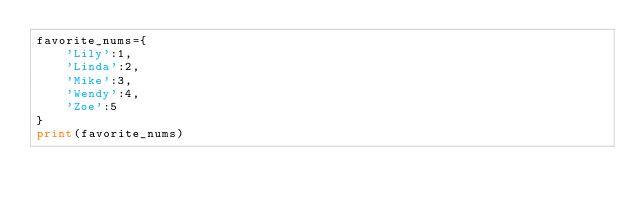Convert code to text. <code><loc_0><loc_0><loc_500><loc_500><_Python_>favorite_nums={
	'Lily':1,
	'Linda':2,
	'Mike':3,
	'Wendy':4,
	'Zoe':5
}
print(favorite_nums)</code> 